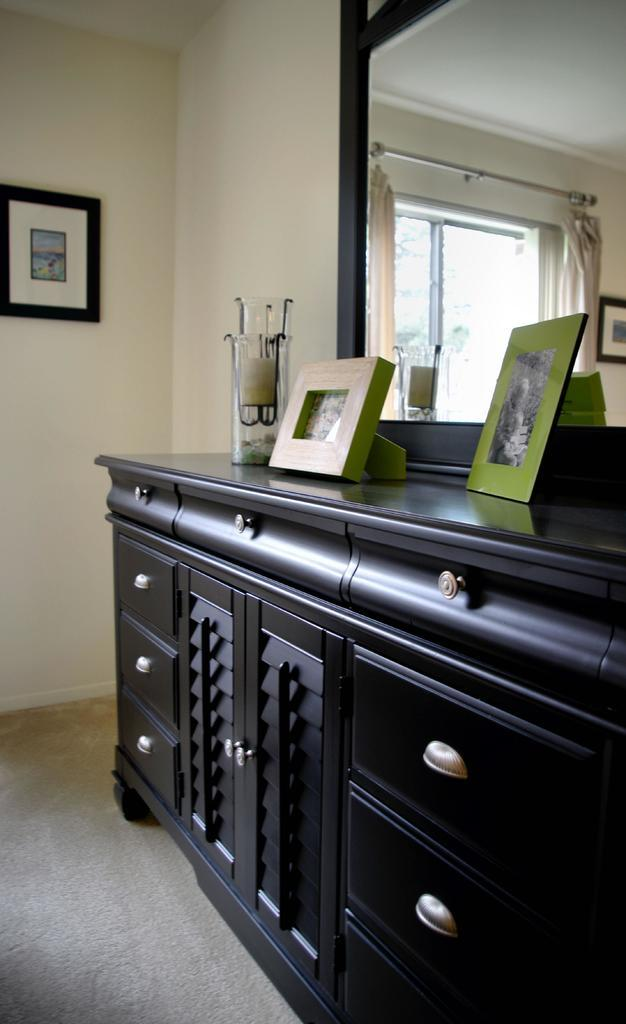What objects in the image are used for displaying photographs? There are photo frames in the image. What type of furniture is present in the image? There is a cupboard in the image. What is hanging on the wall in the image? There is a frame on the wall in the image. What object in the image can be used for checking one's appearance? There is a mirror in the image. How much glue is needed to attach the cakes to the wall in the image? There are no cakes present in the image, so glue is not needed for attaching them to the wall. 